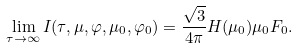Convert formula to latex. <formula><loc_0><loc_0><loc_500><loc_500>\lim _ { \tau \to \infty } I ( \tau , \mu , \varphi , \mu _ { 0 } , \varphi _ { 0 } ) = \frac { \sqrt { 3 } } { 4 \pi } H ( \mu _ { 0 } ) \mu _ { 0 } F _ { 0 } .</formula> 